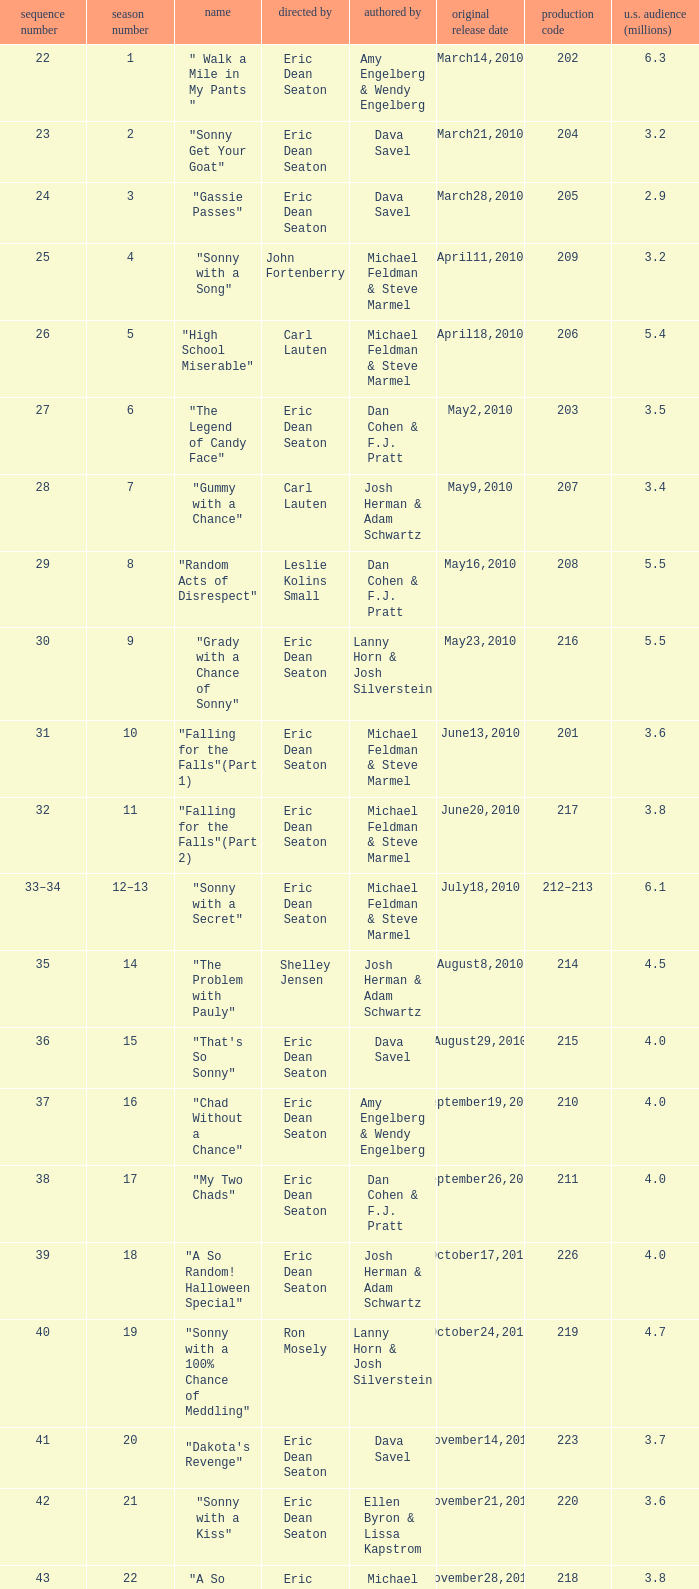Parse the table in full. {'header': ['sequence number', 'season number', 'name', 'directed by', 'authored by', 'original release date', 'production code', 'u.s. audience (millions)'], 'rows': [['22', '1', '" Walk a Mile in My Pants "', 'Eric Dean Seaton', 'Amy Engelberg & Wendy Engelberg', 'March14,2010', '202', '6.3'], ['23', '2', '"Sonny Get Your Goat"', 'Eric Dean Seaton', 'Dava Savel', 'March21,2010', '204', '3.2'], ['24', '3', '"Gassie Passes"', 'Eric Dean Seaton', 'Dava Savel', 'March28,2010', '205', '2.9'], ['25', '4', '"Sonny with a Song"', 'John Fortenberry', 'Michael Feldman & Steve Marmel', 'April11,2010', '209', '3.2'], ['26', '5', '"High School Miserable"', 'Carl Lauten', 'Michael Feldman & Steve Marmel', 'April18,2010', '206', '5.4'], ['27', '6', '"The Legend of Candy Face"', 'Eric Dean Seaton', 'Dan Cohen & F.J. Pratt', 'May2,2010', '203', '3.5'], ['28', '7', '"Gummy with a Chance"', 'Carl Lauten', 'Josh Herman & Adam Schwartz', 'May9,2010', '207', '3.4'], ['29', '8', '"Random Acts of Disrespect"', 'Leslie Kolins Small', 'Dan Cohen & F.J. Pratt', 'May16,2010', '208', '5.5'], ['30', '9', '"Grady with a Chance of Sonny"', 'Eric Dean Seaton', 'Lanny Horn & Josh Silverstein', 'May23,2010', '216', '5.5'], ['31', '10', '"Falling for the Falls"(Part 1)', 'Eric Dean Seaton', 'Michael Feldman & Steve Marmel', 'June13,2010', '201', '3.6'], ['32', '11', '"Falling for the Falls"(Part 2)', 'Eric Dean Seaton', 'Michael Feldman & Steve Marmel', 'June20,2010', '217', '3.8'], ['33–34', '12–13', '"Sonny with a Secret"', 'Eric Dean Seaton', 'Michael Feldman & Steve Marmel', 'July18,2010', '212–213', '6.1'], ['35', '14', '"The Problem with Pauly"', 'Shelley Jensen', 'Josh Herman & Adam Schwartz', 'August8,2010', '214', '4.5'], ['36', '15', '"That\'s So Sonny"', 'Eric Dean Seaton', 'Dava Savel', 'August29,2010', '215', '4.0'], ['37', '16', '"Chad Without a Chance"', 'Eric Dean Seaton', 'Amy Engelberg & Wendy Engelberg', 'September19,2010', '210', '4.0'], ['38', '17', '"My Two Chads"', 'Eric Dean Seaton', 'Dan Cohen & F.J. Pratt', 'September26,2010', '211', '4.0'], ['39', '18', '"A So Random! Halloween Special"', 'Eric Dean Seaton', 'Josh Herman & Adam Schwartz', 'October17,2010', '226', '4.0'], ['40', '19', '"Sonny with a 100% Chance of Meddling"', 'Ron Mosely', 'Lanny Horn & Josh Silverstein', 'October24,2010', '219', '4.7'], ['41', '20', '"Dakota\'s Revenge"', 'Eric Dean Seaton', 'Dava Savel', 'November14,2010', '223', '3.7'], ['42', '21', '"Sonny with a Kiss"', 'Eric Dean Seaton', 'Ellen Byron & Lissa Kapstrom', 'November21,2010', '220', '3.6'], ['43', '22', '"A So Random! Holiday Special"', 'Eric Dean Seaton', 'Michael Feldman & Steve Marmel', 'November28,2010', '218', '3.8'], ['44', '23', '"Sonny with a Grant"', 'Eric Dean Seaton', 'Michael Feldman & Steve Marmel', 'December5,2010', '221', '4.0'], ['45', '24', '"Marshall with a Chance"', 'Shannon Flynn', 'Carla Banks Waddles', 'December12,2010', '224', '3.2'], ['46', '25', '"Sonny with a Choice"', 'Eric Dean Seaton', 'Dan Cohen & F.J. Pratt', 'December19,2010', '222', '4.7']]} How man episodes in the season were titled "that's so sonny"? 1.0. 